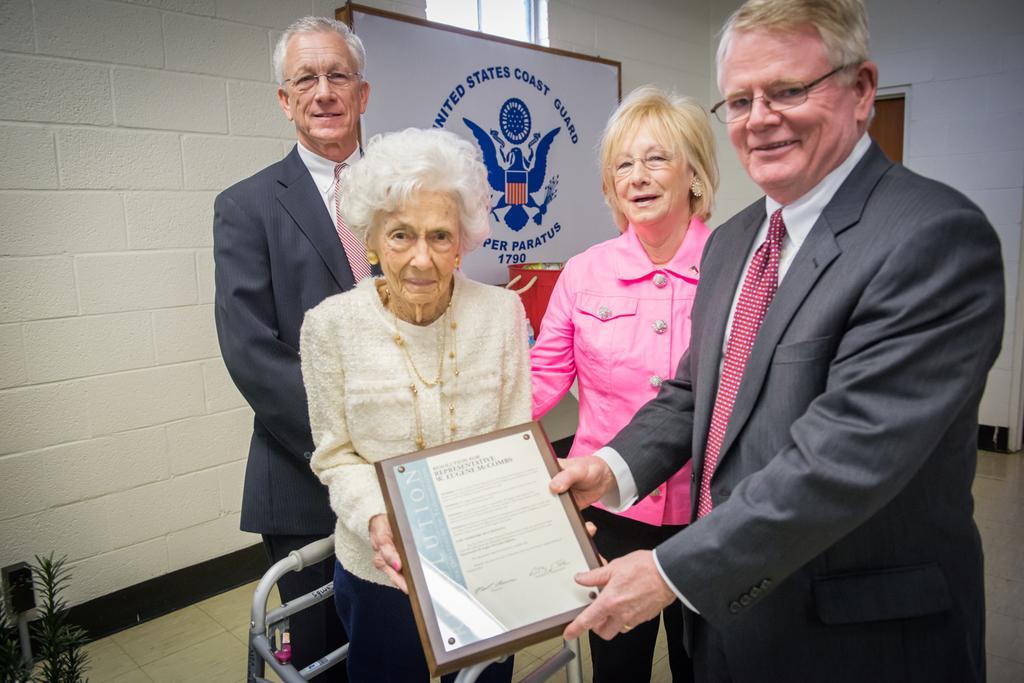Please provide a concise description of this image. In this image we can see two women and two men and a man is presenting award to the old woman who is wearing white color dress and in the background of the image there is a wall. 